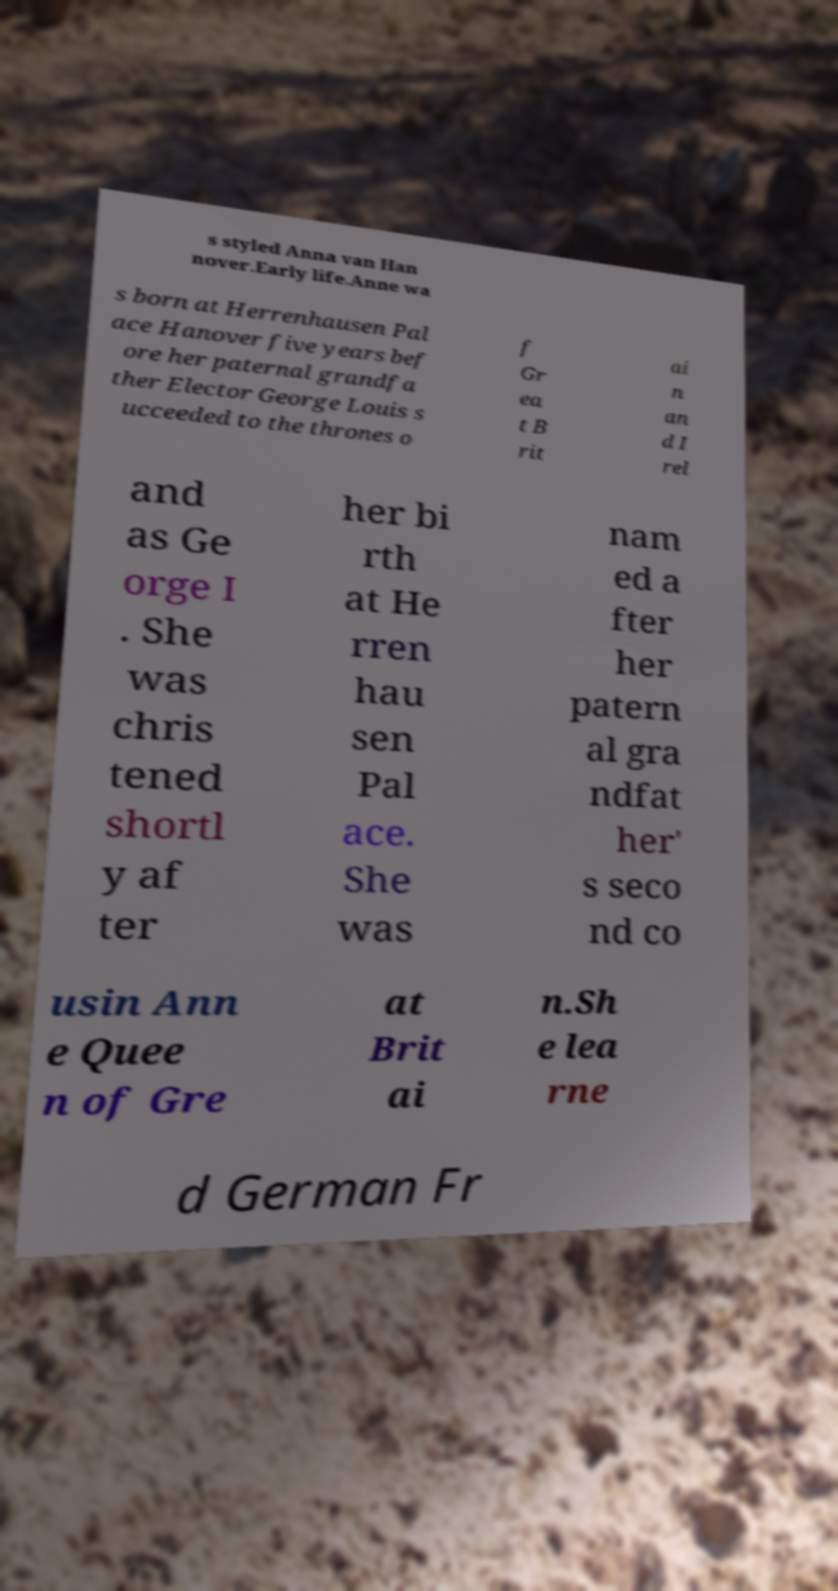Could you assist in decoding the text presented in this image and type it out clearly? s styled Anna van Han nover.Early life.Anne wa s born at Herrenhausen Pal ace Hanover five years bef ore her paternal grandfa ther Elector George Louis s ucceeded to the thrones o f Gr ea t B rit ai n an d I rel and as Ge orge I . She was chris tened shortl y af ter her bi rth at He rren hau sen Pal ace. She was nam ed a fter her patern al gra ndfat her' s seco nd co usin Ann e Quee n of Gre at Brit ai n.Sh e lea rne d German Fr 